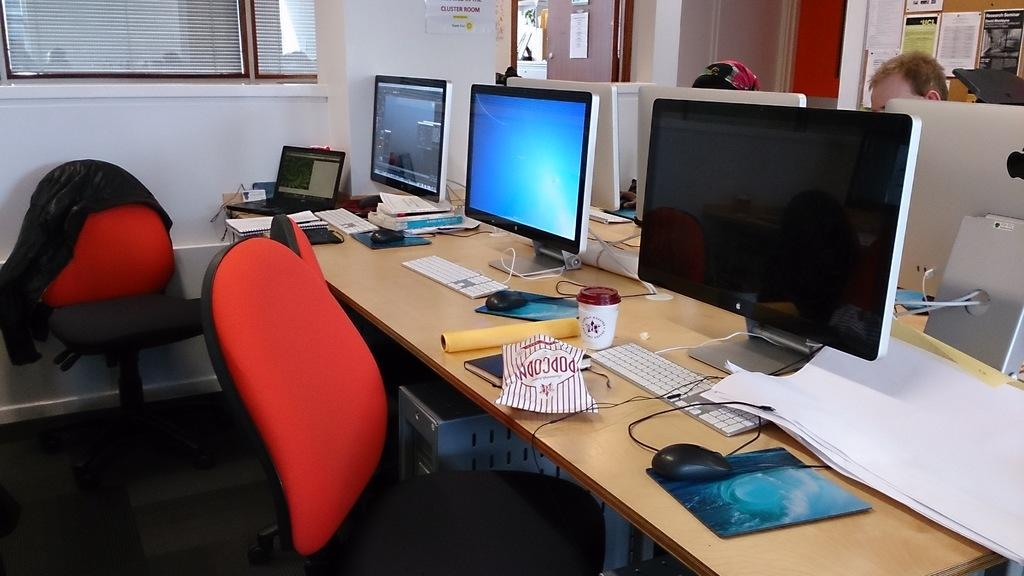<image>
Describe the image concisely. Three computers sit atop a table, and a bag labelled popcorn is in front of one of them. 